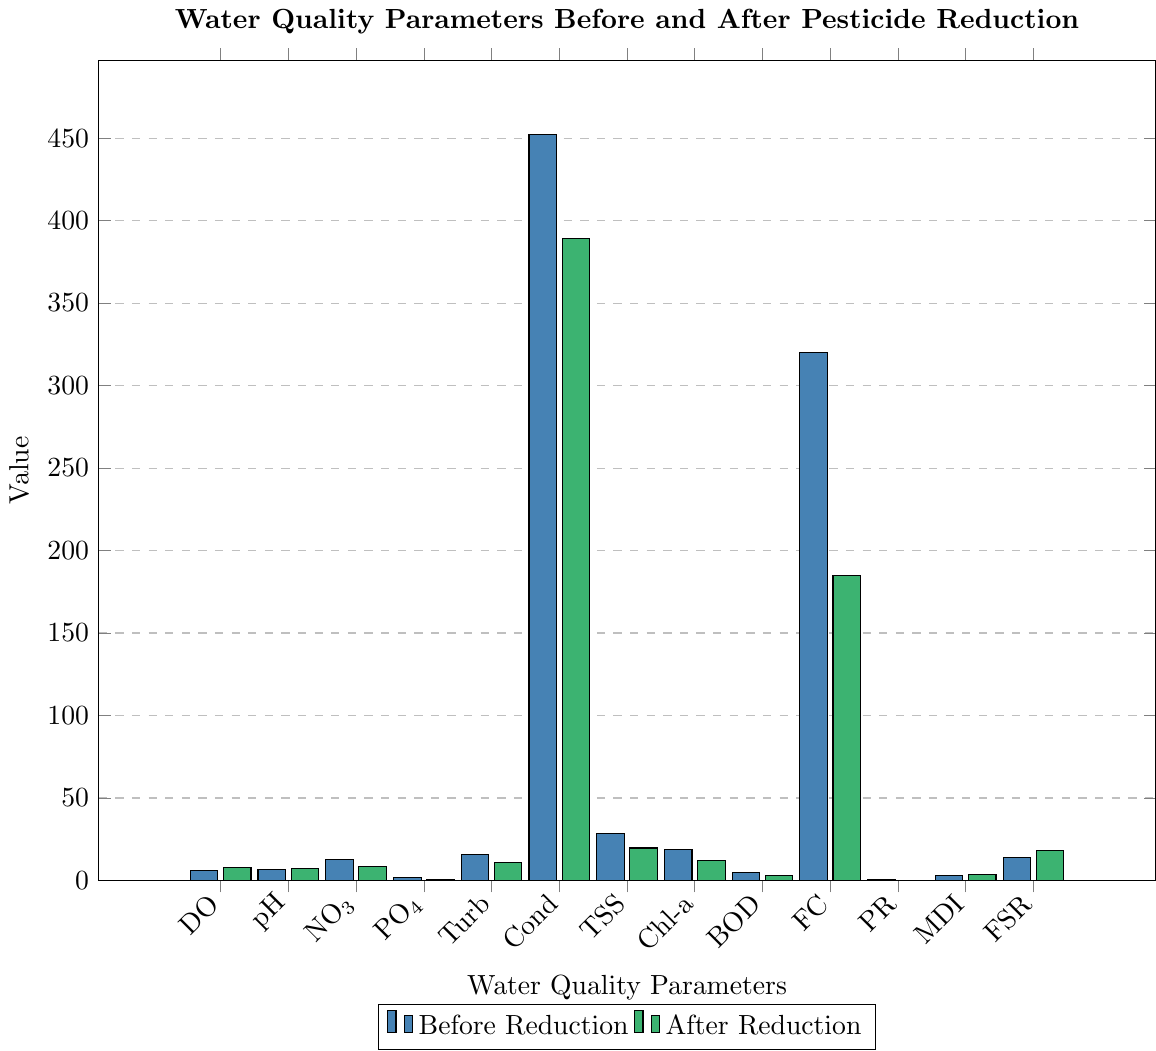Which parameter shows the greatest increase after pesticide reduction? To find the parameter with the greatest increase, calculate the difference between the "After Reduction" and "Before Reduction" values for each parameter, and identify the maximum difference. For Dissolved Oxygen: 7.8 - 6.2 = 1.6; pH: 7.2 - 6.8 = 0.4; Nitrate: 8.3 - 12.5 = -4.2; Phosphate: 0.9 - 1.8 = -0.9; Turbidity: 11.2 - 15.6 = -4.4; Conductivity: 389 - 452 = -63; Total Suspended Solids: 19.7 - 28.3 = -8.6; Chlorophyll-a: 12.4 - 18.9 = -6.5; Biochemical Oxygen Demand: 3.2 - 4.7 = -1.5; Fecal Coliform: 185 - 320 = -135; Pesticide Residue: 0.21 - 0.85 = -0.64; Macroinvertebrate Diversity Index: 3.9 - 2.8 = 1.1; Fish Species Richness: 18 - 14 = 4. The greatest increase is for Fish Species Richness with an increase of 4.
Answer: Fish Species Richness Which parameter has the greatest decrease after pesticide reduction? To determine the parameter with the greatest decrease, calculate the difference between the "Before Reduction" and "After Reduction" values for each parameter and identify the maximum negative difference. Dissolved Oxygen: 7.8-6.2=1.6; pH: 7.2-6.8=0.4; Nitrate: 8.3-12.5= -4.2; Phosphate: 0.9-1.8= -0.9; Turbidity: 11.2-15.6= -4.4; Conductivity: 389-452= -63; Total Suspended Solids: 19.7-28.3= -8.6; Chlorophyll-a: 12.4-18.9= -6.5; Biochemical Oxygen Demand: 3.2-4.7= -1.5; Fecal Coliform: 185-320= -135; Pesticide Residue: 0.21-0.85= -0.64; Macroinvertebrate Diversity Index: 3.9-2.8= 1.1; Fish Species Richness: 18-14=4. The greatest decrease is for Fecal Coliform with a decrease of 135.
Answer: Fecal Coliform What is the combined average value of Dissolved Oxygen before and after pesticide reduction? To find the combined average, add the "Before Reduction" value and the "After Reduction" value for Dissolved Oxygen and then divide by 2. (6.2 + 7.8) / 2 = 7.0
Answer: 7.0 Which parameter had almost no change visually observable in the bar chart? Compare the lengths of the bars for each parameter before and after. The parameter with bars of nearly equal length will have had almost no change. Both pH and Pesticide Residue have small differences visually, but pH shows the least change.
Answer: pH How much lower is the Nitrate concentration after the pesticide reduction compared to before? Subtract the "After Reduction" value from the "Before Reduction" value for Nitrate. 12.5 - 8.3 = 4.2
Answer: 4.2 Which parameter shows a notable improvement in water quality, and what indicates this improvement? A notable improvement in water quality can be inferred from a significant decrease in harmful substance concentrations. Visually, Pesticide Residue shows a significant drop from 0.85 µg/L to 0.21 µg/L, which indicates a notable improvement.
Answer: Pesticide Residue How many parameters show improvement (either increase in beneficial or decrease in harmful values) after pesticide reduction? To determine this, count the parameters that either increased in beneficial values (like DO, pH, Macroinvertebrate Diversity Index, Fish Species Richness) or decreased in harmful values (like Nitrate, Phosphate, Turbidity, Conductivity, Total Suspended Solids, Chlorophyll-a, Biochemical Oxygen Demand, Fecal Coliform, Pesticide Residue). All parameters except pH show improvement. There are 11 parameters showing improvement.
Answer: 11 Are there any parameters where the reduction in pesticide does not seem to have a significant impact? By comparing the "Before" and "After" bars visually, parameters like pH show minimal change. This suggests that pesticide reduction did not significantly impact the pH levels.
Answer: pH 